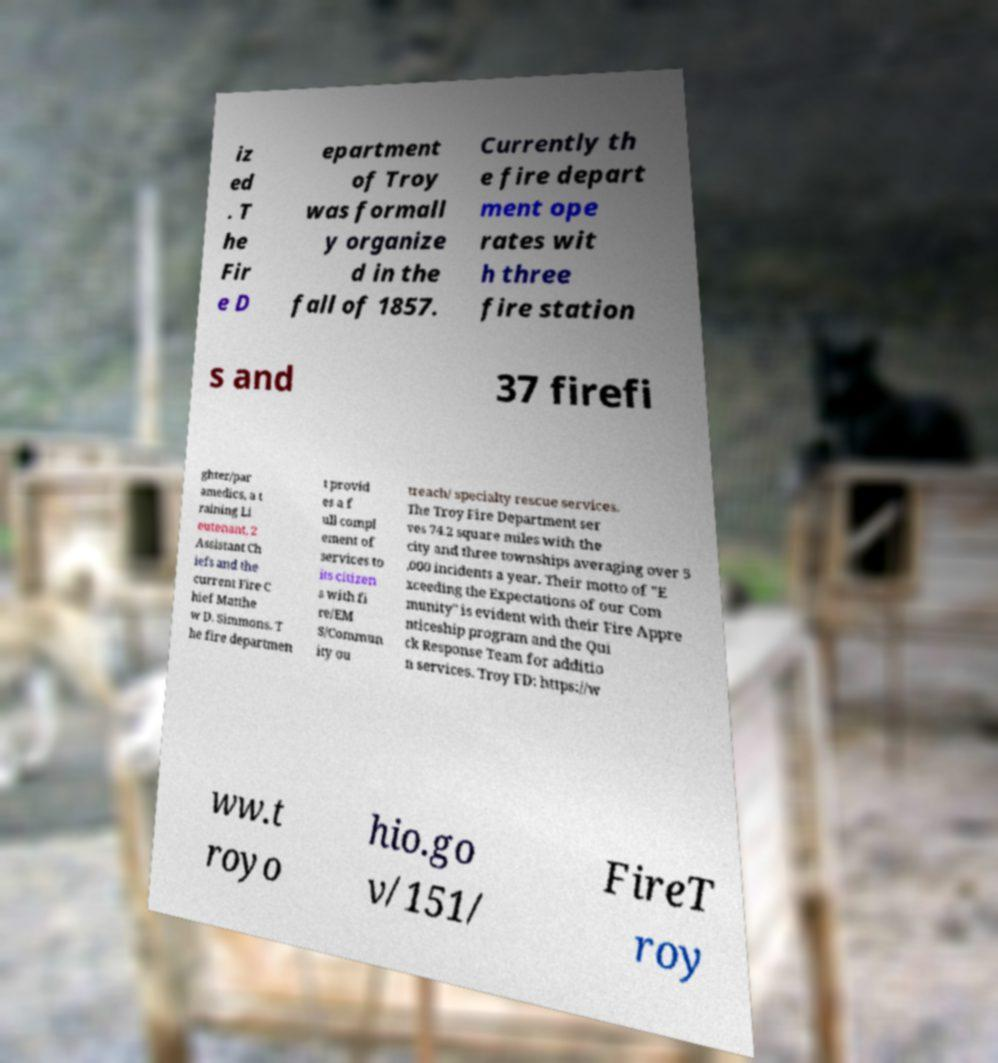There's text embedded in this image that I need extracted. Can you transcribe it verbatim? iz ed . T he Fir e D epartment of Troy was formall y organize d in the fall of 1857. Currently th e fire depart ment ope rates wit h three fire station s and 37 firefi ghter/par amedics, a t raining Li eutenant, 2 Assistant Ch iefs and the current Fire C hief Matthe w D. Simmons. T he fire departmen t provid es a f ull compl ement of services to its citizen s with fi re/EM S/Commun ity ou treach/ specialty rescue services. The Troy Fire Department ser ves 74.2 square miles with the city and three townships averaging over 5 ,000 incidents a year. Their motto of "E xceeding the Expectations of our Com munity" is evident with their Fire Appre nticeship program and the Qui ck Response Team for additio n services. Troy FD: https://w ww.t royo hio.go v/151/ FireT roy 